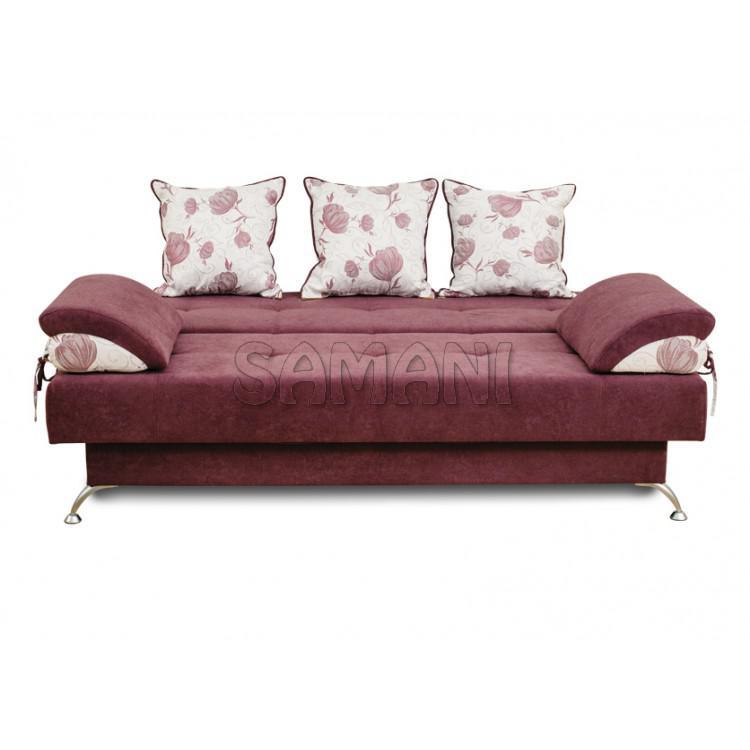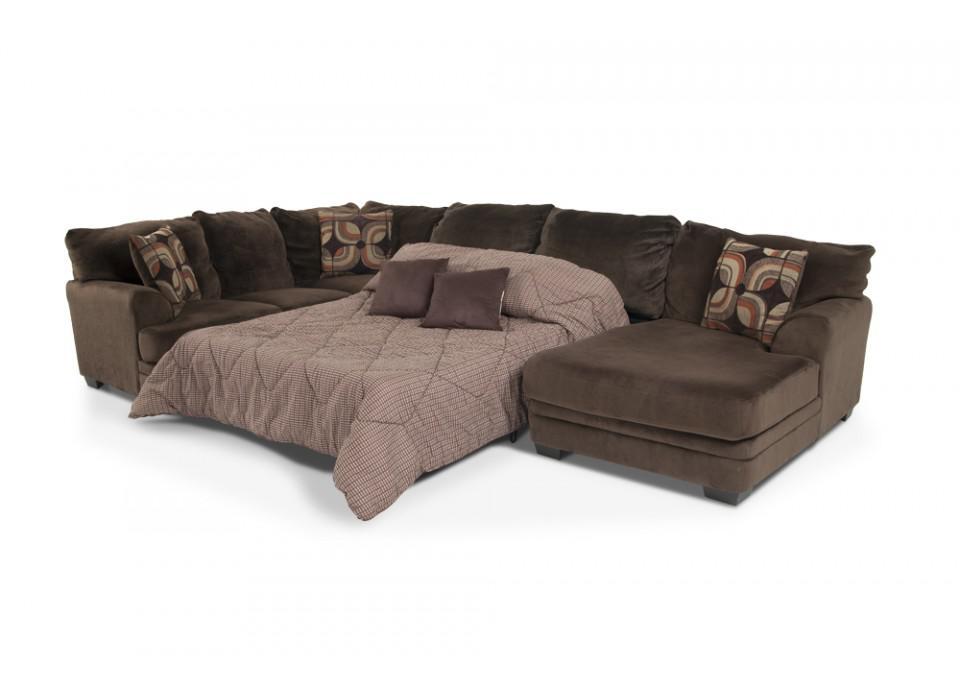The first image is the image on the left, the second image is the image on the right. Considering the images on both sides, is "There are a total of 8 throw pillows." valid? Answer yes or no. Yes. 